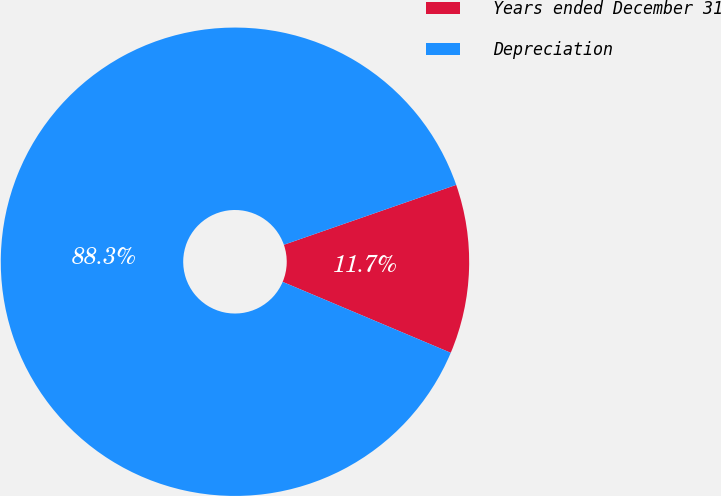<chart> <loc_0><loc_0><loc_500><loc_500><pie_chart><fcel>Years ended December 31<fcel>Depreciation<nl><fcel>11.68%<fcel>88.32%<nl></chart> 